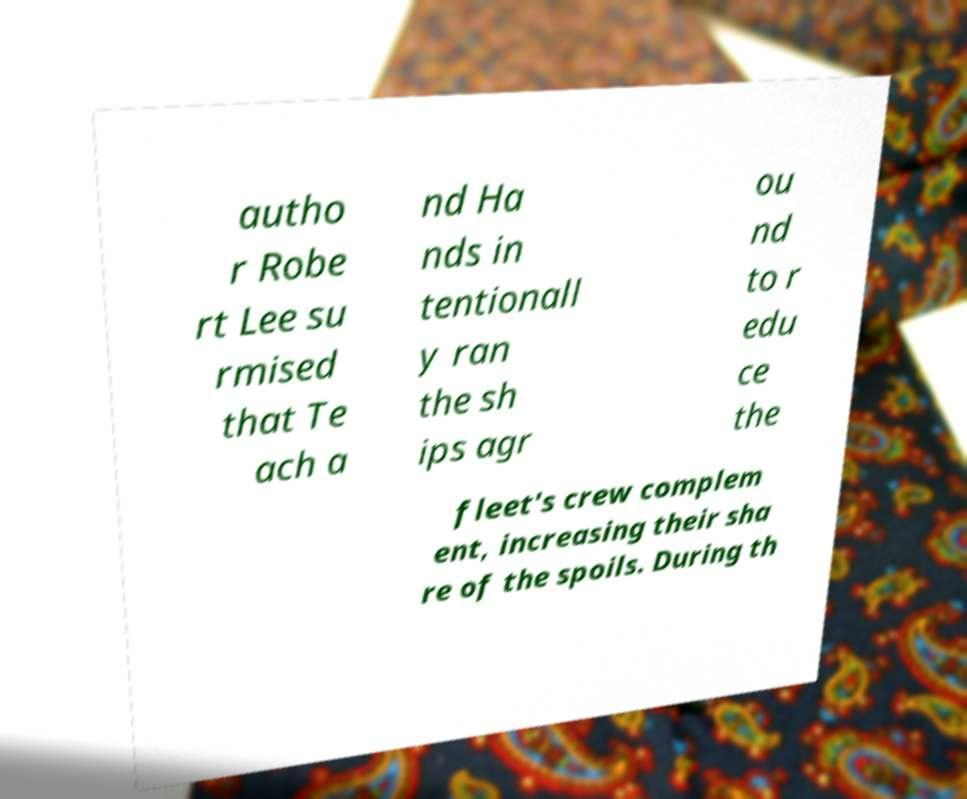I need the written content from this picture converted into text. Can you do that? autho r Robe rt Lee su rmised that Te ach a nd Ha nds in tentionall y ran the sh ips agr ou nd to r edu ce the fleet's crew complem ent, increasing their sha re of the spoils. During th 